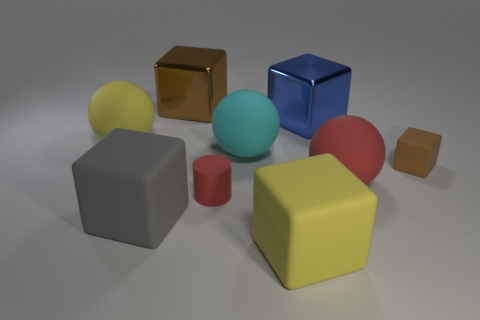Subtract all big gray matte cubes. How many cubes are left? 4 Subtract all spheres. How many objects are left? 6 Subtract all red spheres. How many spheres are left? 2 Subtract 5 blocks. How many blocks are left? 0 Subtract all gray spheres. Subtract all blue cylinders. How many spheres are left? 3 Subtract all blue balls. How many brown cubes are left? 2 Subtract all matte balls. Subtract all shiny things. How many objects are left? 4 Add 4 gray matte things. How many gray matte things are left? 5 Add 3 tiny green matte blocks. How many tiny green matte blocks exist? 3 Subtract 0 brown balls. How many objects are left? 9 